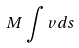Convert formula to latex. <formula><loc_0><loc_0><loc_500><loc_500>M \int v d s</formula> 